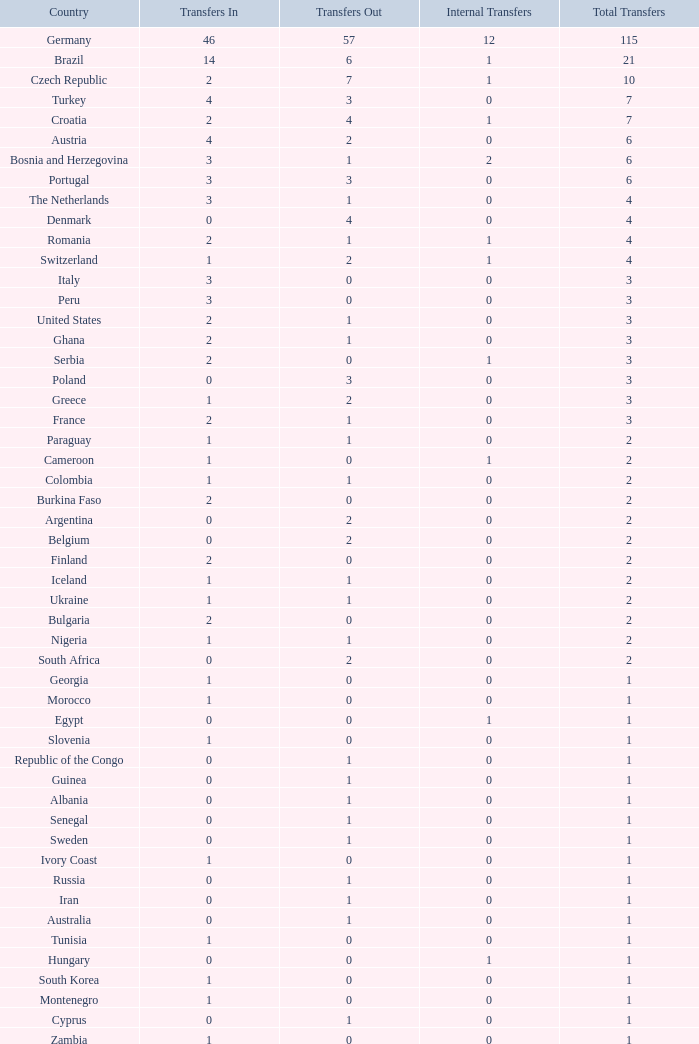What are the Transfers out for Peru? 0.0. 